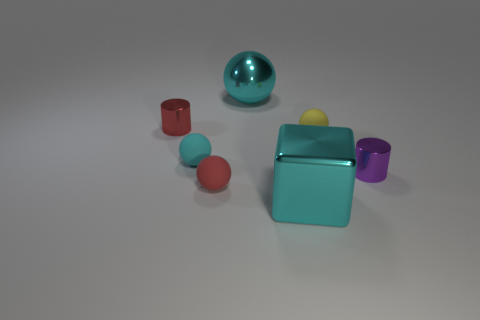What size is the object that is behind the small cyan ball and in front of the red metallic thing?
Provide a short and direct response. Small. There is a tiny object that is both behind the tiny cyan ball and on the left side of the yellow sphere; what color is it?
Offer a terse response. Red. Are there fewer cyan shiny things to the left of the small red matte object than tiny red shiny things that are to the left of the large cyan metal block?
Offer a very short reply. Yes. What shape is the tiny purple metal thing?
Keep it short and to the point. Cylinder. There is another small cylinder that is the same material as the purple cylinder; what is its color?
Give a very brief answer. Red. Are there more shiny cubes than rubber objects?
Ensure brevity in your answer.  No. Is there a small gray matte ball?
Your answer should be very brief. No. What shape is the cyan metal object in front of the tiny matte sphere on the right side of the big cyan metal cube?
Offer a very short reply. Cube. What number of things are either large metallic objects or tiny purple shiny objects that are in front of the big cyan sphere?
Provide a short and direct response. 3. There is a small metallic thing left of the large object that is right of the big cyan object on the left side of the cube; what color is it?
Your answer should be very brief. Red. 